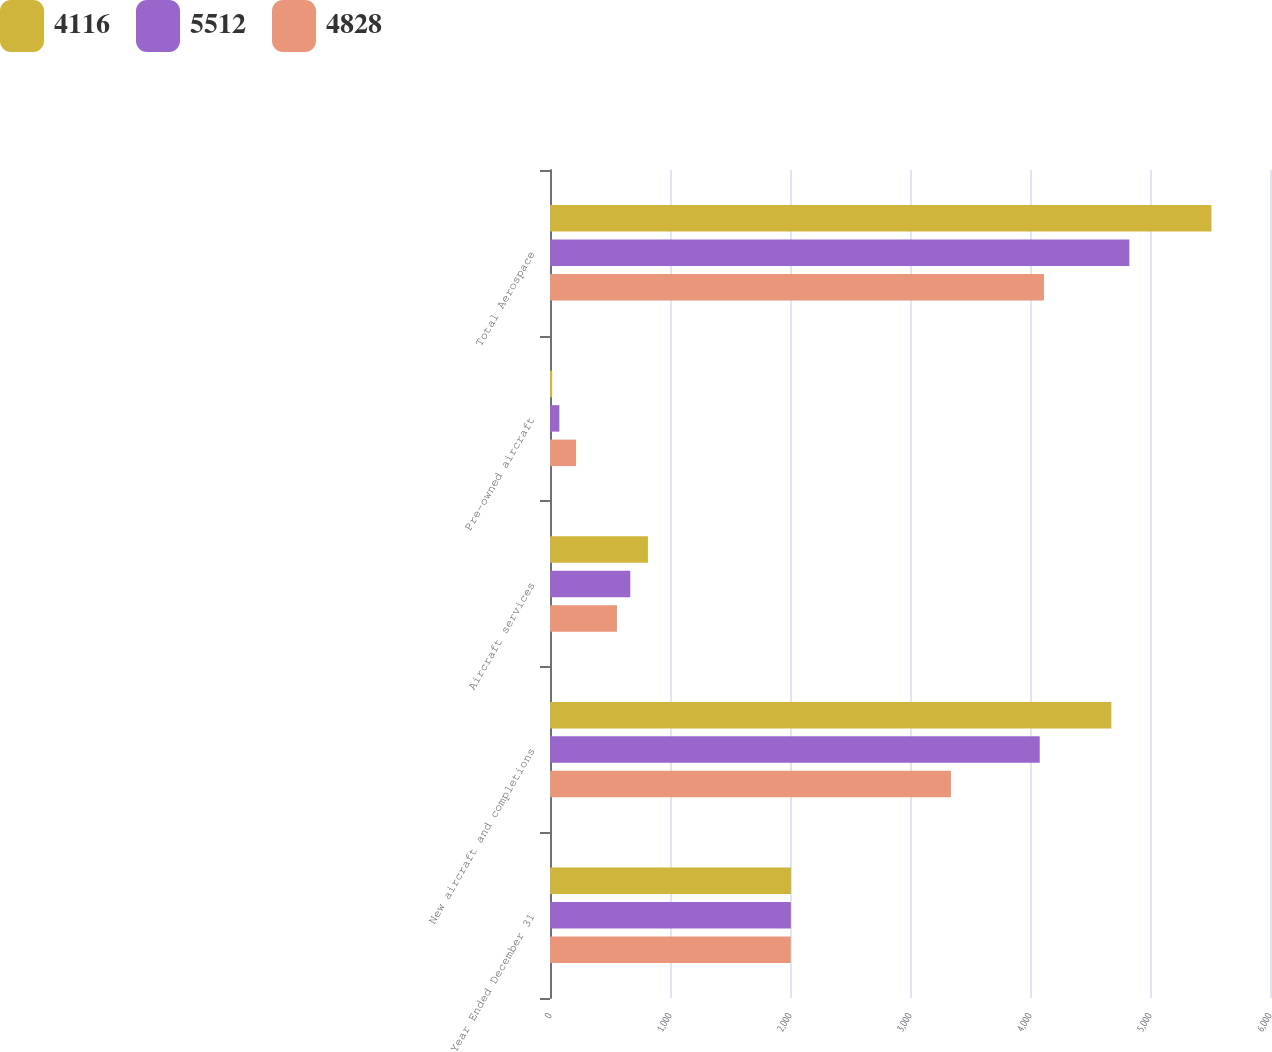<chart> <loc_0><loc_0><loc_500><loc_500><stacked_bar_chart><ecel><fcel>Year Ended December 31<fcel>New aircraft and completions<fcel>Aircraft services<fcel>Pre-owned aircraft<fcel>Total Aerospace<nl><fcel>4116<fcel>2008<fcel>4678<fcel>816<fcel>18<fcel>5512<nl><fcel>5512<fcel>2007<fcel>4081<fcel>669<fcel>78<fcel>4828<nl><fcel>4828<fcel>2006<fcel>3341<fcel>558<fcel>217<fcel>4116<nl></chart> 